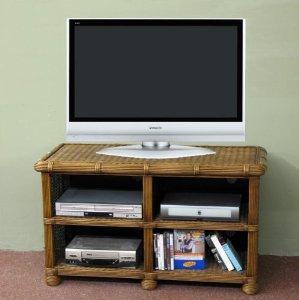How many shelves are pictured?
Give a very brief answer. 4. 